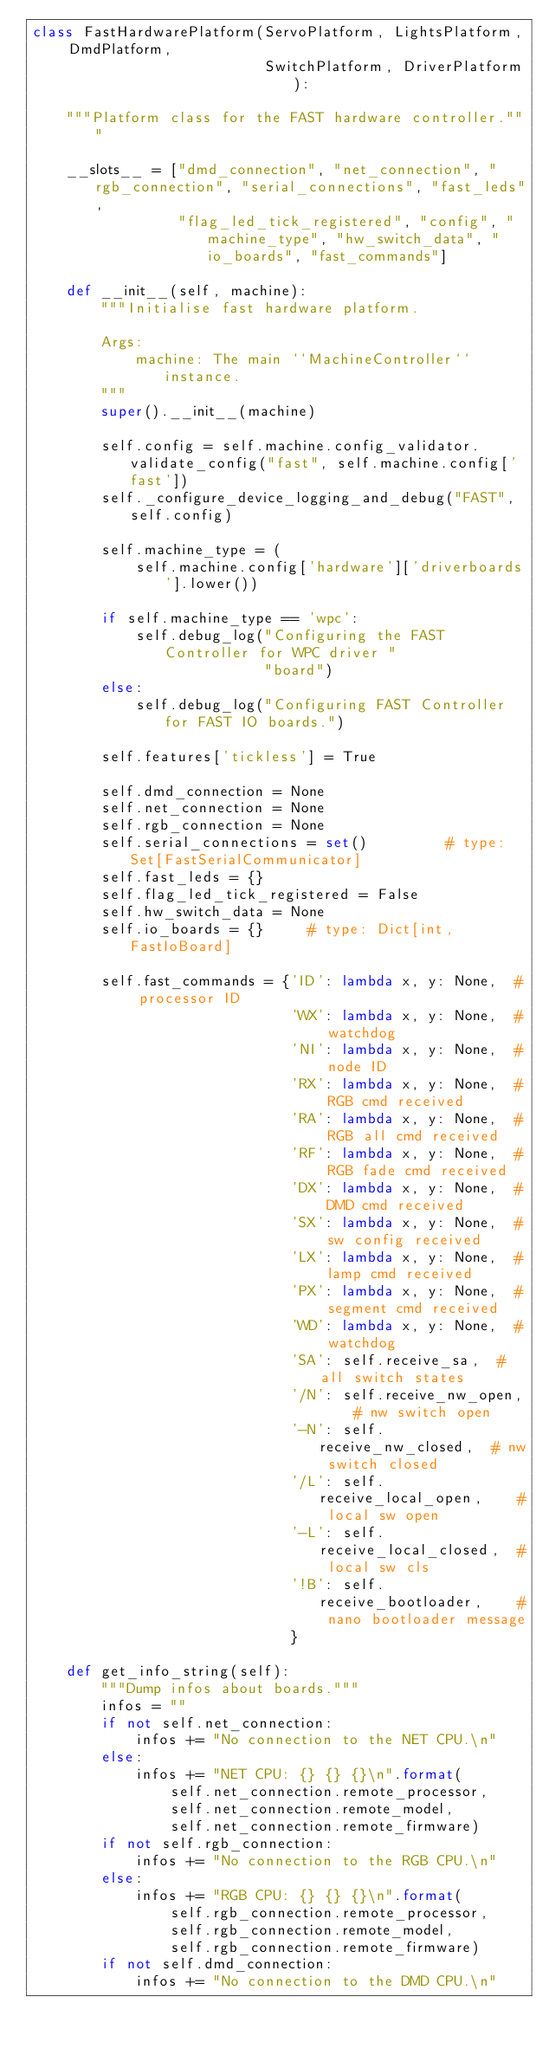Convert code to text. <code><loc_0><loc_0><loc_500><loc_500><_Python_>class FastHardwarePlatform(ServoPlatform, LightsPlatform, DmdPlatform,
                           SwitchPlatform, DriverPlatform):

    """Platform class for the FAST hardware controller."""

    __slots__ = ["dmd_connection", "net_connection", "rgb_connection", "serial_connections", "fast_leds",
                 "flag_led_tick_registered", "config", "machine_type", "hw_switch_data", "io_boards", "fast_commands"]

    def __init__(self, machine):
        """Initialise fast hardware platform.

        Args:
            machine: The main ``MachineController`` instance.
        """
        super().__init__(machine)

        self.config = self.machine.config_validator.validate_config("fast", self.machine.config['fast'])
        self._configure_device_logging_and_debug("FAST", self.config)

        self.machine_type = (
            self.machine.config['hardware']['driverboards'].lower())

        if self.machine_type == 'wpc':
            self.debug_log("Configuring the FAST Controller for WPC driver "
                           "board")
        else:
            self.debug_log("Configuring FAST Controller for FAST IO boards.")

        self.features['tickless'] = True

        self.dmd_connection = None
        self.net_connection = None
        self.rgb_connection = None
        self.serial_connections = set()         # type: Set[FastSerialCommunicator]
        self.fast_leds = {}
        self.flag_led_tick_registered = False
        self.hw_switch_data = None
        self.io_boards = {}     # type: Dict[int, FastIoBoard]

        self.fast_commands = {'ID': lambda x, y: None,  # processor ID
                              'WX': lambda x, y: None,  # watchdog
                              'NI': lambda x, y: None,  # node ID
                              'RX': lambda x, y: None,  # RGB cmd received
                              'RA': lambda x, y: None,  # RGB all cmd received
                              'RF': lambda x, y: None,  # RGB fade cmd received
                              'DX': lambda x, y: None,  # DMD cmd received
                              'SX': lambda x, y: None,  # sw config received
                              'LX': lambda x, y: None,  # lamp cmd received
                              'PX': lambda x, y: None,  # segment cmd received
                              'WD': lambda x, y: None,  # watchdog
                              'SA': self.receive_sa,  # all switch states
                              '/N': self.receive_nw_open,    # nw switch open
                              '-N': self.receive_nw_closed,  # nw switch closed
                              '/L': self.receive_local_open,    # local sw open
                              '-L': self.receive_local_closed,  # local sw cls
                              '!B': self.receive_bootloader,    # nano bootloader message
                              }

    def get_info_string(self):
        """Dump infos about boards."""
        infos = ""
        if not self.net_connection:
            infos += "No connection to the NET CPU.\n"
        else:
            infos += "NET CPU: {} {} {}\n".format(
                self.net_connection.remote_processor,
                self.net_connection.remote_model,
                self.net_connection.remote_firmware)
        if not self.rgb_connection:
            infos += "No connection to the RGB CPU.\n"
        else:
            infos += "RGB CPU: {} {} {}\n".format(
                self.rgb_connection.remote_processor,
                self.rgb_connection.remote_model,
                self.rgb_connection.remote_firmware)
        if not self.dmd_connection:
            infos += "No connection to the DMD CPU.\n"</code> 